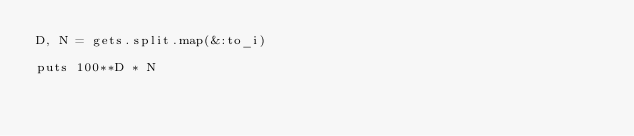Convert code to text. <code><loc_0><loc_0><loc_500><loc_500><_Ruby_>D, N = gets.split.map(&:to_i)

puts 100**D * N</code> 